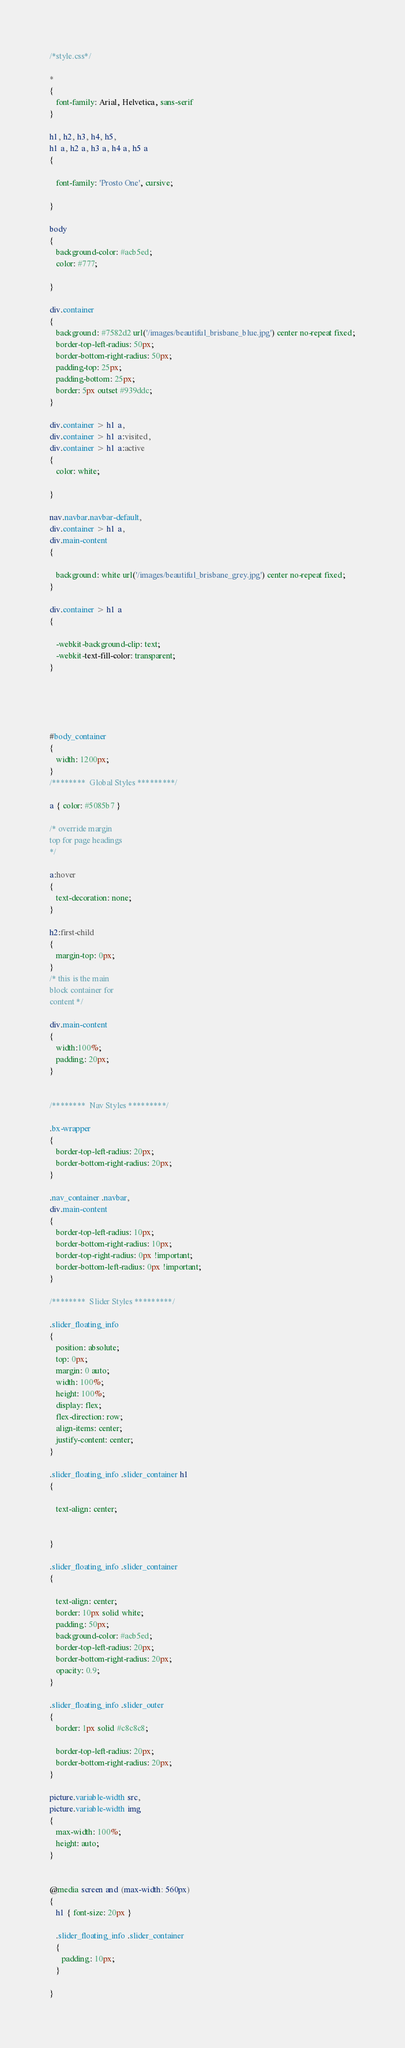Convert code to text. <code><loc_0><loc_0><loc_500><loc_500><_CSS_>/*style.css*/

* 
{
   font-family: Arial, Helvetica, sans-serif
}

h1, h2, h3, h4, h5,
h1 a, h2 a, h3 a, h4 a, h5 a
{

   font-family: 'Prosto One', cursive;
  
}

body
{
   background-color: #acb5ed;
   color: #777;
   
}

div.container
{
   background: #7582d2 url('/images/beautiful_brisbane_blue.jpg') center no-repeat fixed;
   border-top-left-radius: 50px;
   border-bottom-right-radius: 50px;
   padding-top: 25px;
   padding-bottom: 25px;
   border: 5px outset #939ddc;
}

div.container > h1 a,
div.container > h1 a:visited,
div.container > h1 a:active
{
   color: white;
   
}

nav.navbar.navbar-default,
div.container > h1 a,
div.main-content
{
 
   background: white url('/images/beautiful_brisbane_grey.jpg') center no-repeat fixed;
}

div.container > h1 a
{
   
   -webkit-background-clip: text;
   -webkit-text-fill-color: transparent;
}





#body_container
{
   width: 1200px;
}
/********  Global Styles *********/

a { color: #5085b7 }

/* override margin
top for page headings
*/

a:hover
{
   text-decoration: none;
}

h2:first-child
{
   margin-top: 0px;
}
/* this is the main 
block container for 
content */

div.main-content
{
   width:100%;
   padding: 20px;
}


/********  Nav Styles *********/

.bx-wrapper
{
   border-top-left-radius: 20px;
   border-bottom-right-radius: 20px;
}

.nav_container .navbar,
div.main-content
{
   border-top-left-radius: 10px;
   border-bottom-right-radius: 10px;
   border-top-right-radius: 0px !important;
   border-bottom-left-radius: 0px !important;
}

/********  Slider Styles *********/

.slider_floating_info
{
   position: absolute;
   top: 0px;
   margin: 0 auto;
   width: 100%;
   height: 100%;
   display: flex;
   flex-direction: row;
   align-items: center;
   justify-content: center;
}

.slider_floating_info .slider_container h1
{
   
   text-align: center;
   
  
}

.slider_floating_info .slider_container
{
   
   text-align: center;
   border: 10px solid white;
   padding: 50px;
   background-color: #acb5ed;
   border-top-left-radius: 20px;
   border-bottom-right-radius: 20px;
   opacity: 0.9;
}

.slider_floating_info .slider_outer
{
   border: 1px solid #c8c8c8;
   
   border-top-left-radius: 20px;
   border-bottom-right-radius: 20px;
}

picture.variable-width src,
picture.variable-width img
{
   max-width: 100%;
   height: auto;
}


@media screen and (max-width: 560px)
{
   h1 { font-size: 20px }
   
   .slider_floating_info .slider_container
   {
      padding: 10px;
   }

}


</code> 